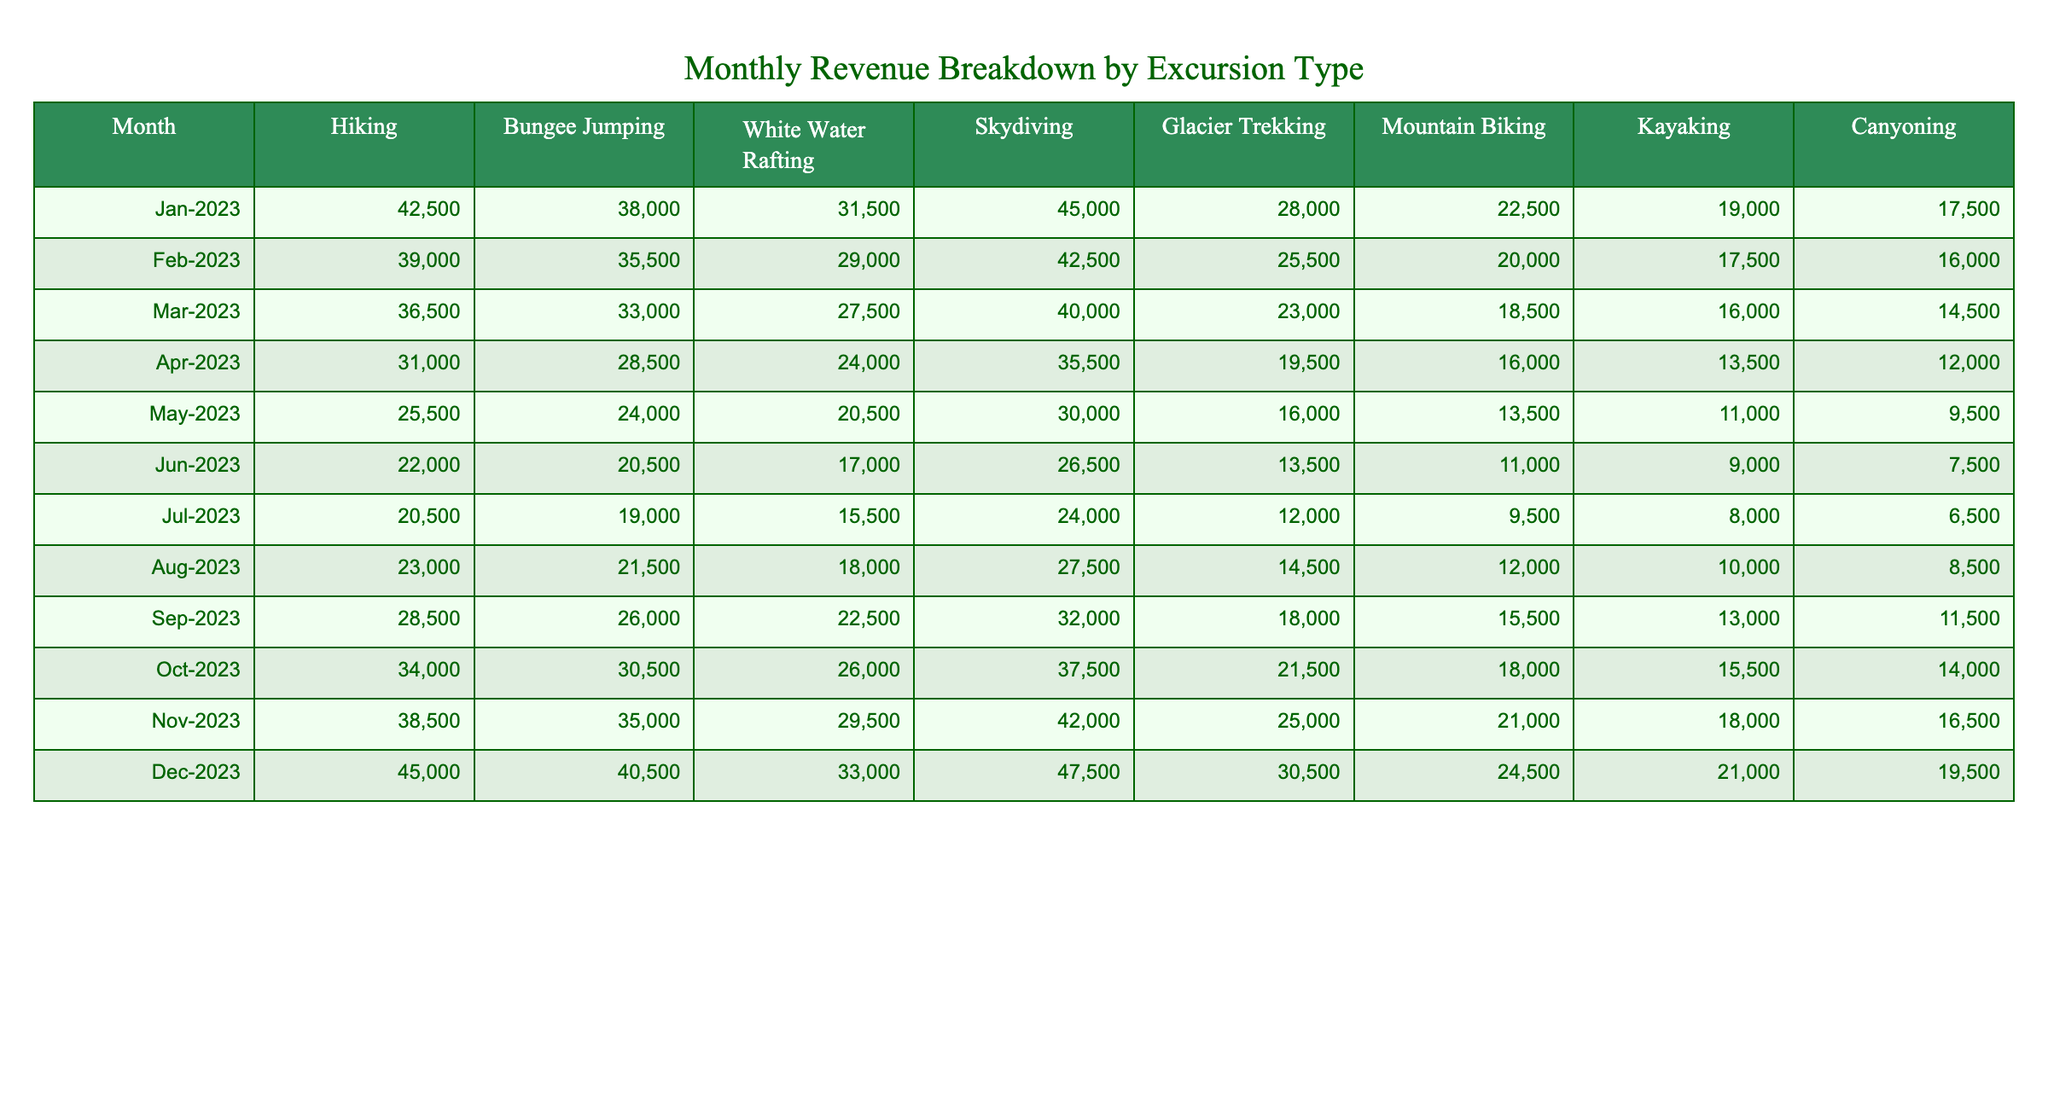What was the highest revenue generated from Skydiving in any month? The table shows the revenue for Skydiving each month, with the maximum value found in December 2023 at 47,500.
Answer: 47,500 In which month did Hiking bring in the least revenue? Looking at the Hiking column, the lowest revenue is found in May 2023, with 25,500.
Answer: May 2023 What is the total revenue from Mountain Biking for the entire year? To find this, I add the values from the Mountain Biking column: 22,500 + 20,000 + 18,500 + 16,000 + 13,500 + 11,000 + 9,500 + 12,000 + 15,500 + 18,000 + 21,000 + 24,500 =  212,500.
Answer: 212,500 Did the revenue from Canyoning ever exceed that from Kayaking? By comparing the values in both columns month by month, Canyoning's revenue was above Kayaking's only in the months of December 2023 and November 2023. Thus, the statement is true.
Answer: Yes Which excursion type had the highest average revenue across the year? We need to find the average revenue for each excursion type: Hiking (29,208.33), Bungee Jumping (29,583.33), White Water Rafting (25,833.33), Skydiving (34,583.33), Glacier Trekking (21,666.67), Mountain Biking (17,916.67), Kayaking (14,166.67), and Canyoning (12,041.67). Skydiving has the highest average, at approximately 34,583.33.
Answer: Skydiving What was the difference in revenue between the highest and lowest month for White Water Rafting? Looking at the White Water Rafting column, the highest was in December at 33,000 and the lowest was in May at 20,500. So the difference is 33,000 - 20,500 = 12,500.
Answer: 12,500 How much more revenue was generated from Bungee Jumping compared to Glacier Trekking in November 2023? In November 2023, Bungee Jumping earned 35,000, and Glacier Trekking earned 25,000. The difference is 35,000 - 25,000 = 10,000.
Answer: 10,000 Which month experienced the largest decline in revenue for Kayaking? We examine the Kayaking column for changes in revenue month over month. The largest decline went from 13,000 in September to 10,000 in August, a drop of 3,000.
Answer: 3,000 What is the trend observed in the revenues for Hiking over the months? Reviewing the Hiking column, the revenue generally decreases from January to May, then gradually increases again from June to December, indicating a seasonal trend.
Answer: Decreasing then increasing Did the total revenue from all excursion types in December surpass1,000,000? Adding the total revenue from all excursion types in December (45,000 + 40,500 + 33,000 + 47,500 + 30,500 + 24,500 + 21,000 + 19,500) gives 291,500, which does not exceed 1,000,000.
Answer: No 